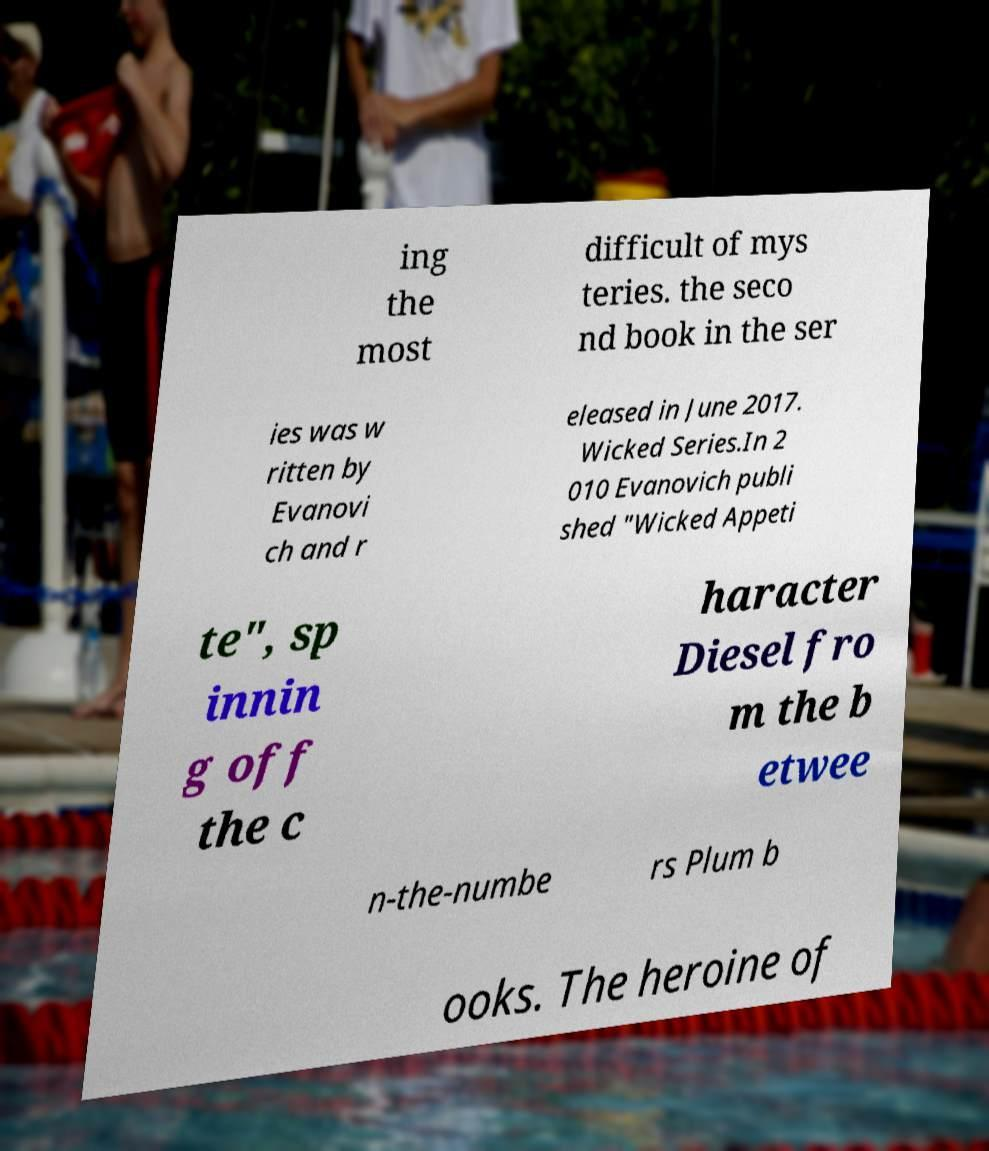For documentation purposes, I need the text within this image transcribed. Could you provide that? ing the most difficult of mys teries. the seco nd book in the ser ies was w ritten by Evanovi ch and r eleased in June 2017. Wicked Series.In 2 010 Evanovich publi shed "Wicked Appeti te", sp innin g off the c haracter Diesel fro m the b etwee n-the-numbe rs Plum b ooks. The heroine of 